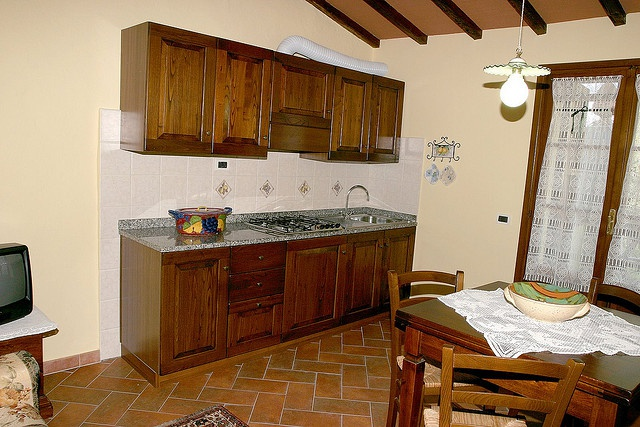Describe the objects in this image and their specific colors. I can see dining table in tan, lightgray, maroon, black, and olive tones, chair in tan, brown, maroon, and black tones, chair in tan, maroon, black, and olive tones, couch in tan and gray tones, and bowl in tan, beige, and olive tones in this image. 